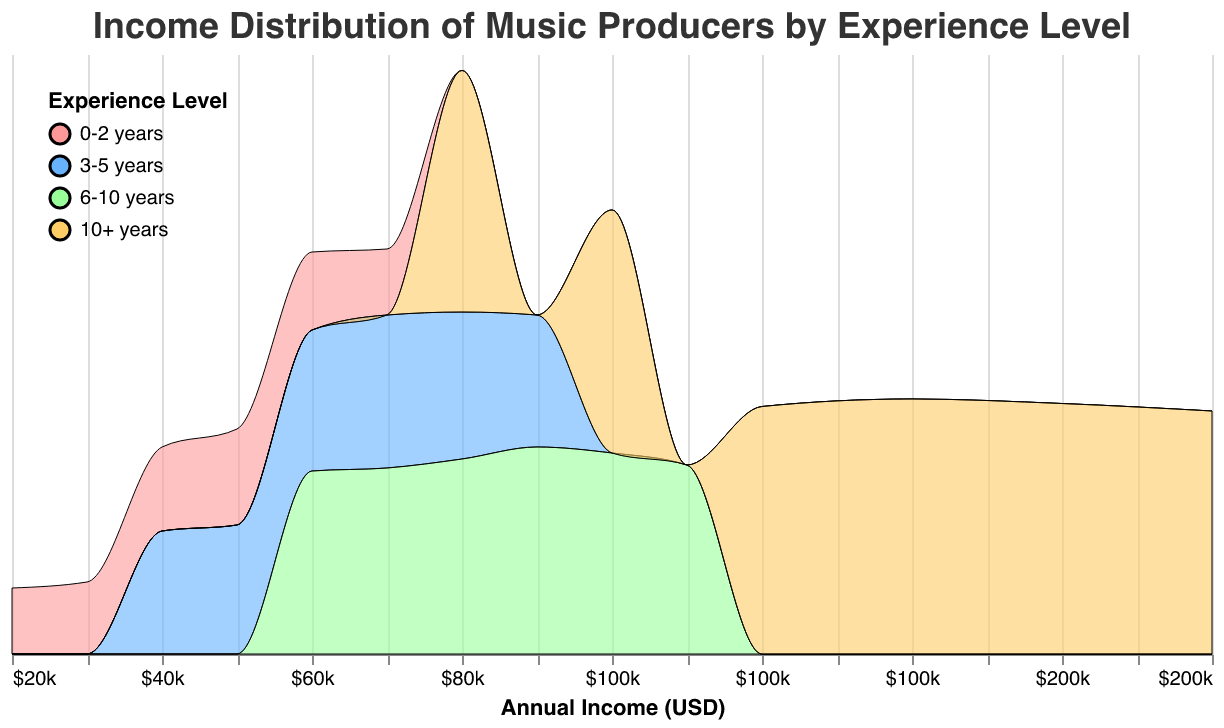What is the title of the plot? The title is located at the top of the plot and usually provides a summary of what the plot represents.
Answer: Income Distribution of Music Producers by Experience Level What does the x-axis represent? The x-axis is labeled as "Annual Income (USD)" which indicates it shows various income levels in USD for the music producers.
Answer: Annual Income (USD) What are the experience levels represented in different colors? The legend at the top-left corner of the plot shows different colors for each experience level. These are "0-2 years," "3-5 years," "6-10 years," and "10+ years."
Answer: 0-2 years, 3-5 years, 6-10 years, 10+ years Which experience level has the widest income distribution? The width of the distributions shows how spread out the incomes are for each experience level. The income distribution for "10+ years" appears to be the widest, ranging from $80,000 to $180,000.
Answer: 10+ years Which experience level has the highest peak in density? The highest peak in density corresponds to the greatest frequency of incomes within that range. The peak for "0-2 years" appears to be the highest at the $50,000 mark.
Answer: 0-2 years Which experience level shows the highest income in the dataset? By looking at the far right of the plot for each colored distribution, the highest income appears in the "10+ years" category, at $180,000.
Answer: 10+ years At what income does the experience level "3-5 years" have its highest density? For the "3-5 years" experience level, the highest point of the plot indicates the income with the highest density. This income level is $70,000.
Answer: $70,000 How does the income distribution for "6-10 years" compare to "10+ years"? Comparing the shapes and spreads of the two distributions, the income range for "6-10 years" is from $60,000 to $110,000, while for "10+ years" it ranges from $80,000 to $180,000. The "10+ years" group not only covers a higher range but also reaches higher incomes.
Answer: The "10+ years" group has a higher and wider income range At what income level does the "0-2 years" experience level's density start to decrease? Observing the peak and decline of the "0-2 years" distribution, the density starts to decrease after the $50,000 mark.
Answer: $50,000 What is the common income range for producers with "6-10 years" of experience where the density is notably higher? The density is notably higher between $80,000 and $100,000 for those with "6-10 years" of experience. This is where the plot rises and shows a considerable density.
Answer: $80,000 to $100,000 